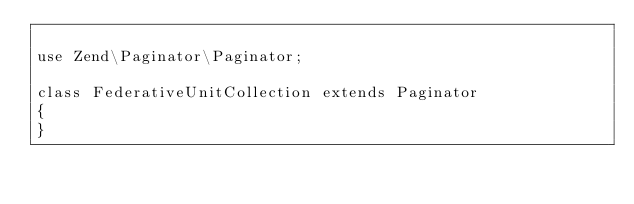<code> <loc_0><loc_0><loc_500><loc_500><_PHP_>
use Zend\Paginator\Paginator;

class FederativeUnitCollection extends Paginator
{
}
</code> 